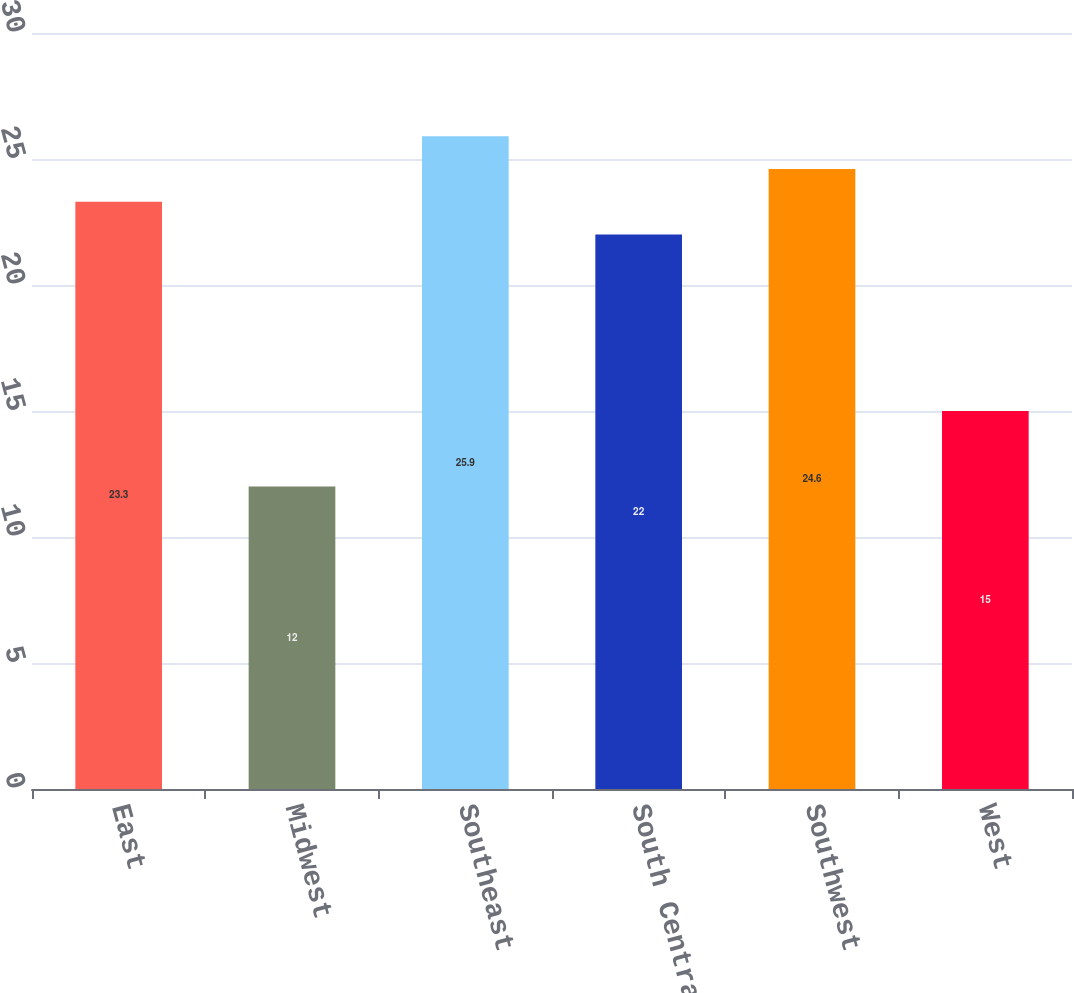Convert chart. <chart><loc_0><loc_0><loc_500><loc_500><bar_chart><fcel>East<fcel>Midwest<fcel>Southeast<fcel>South Central<fcel>Southwest<fcel>West<nl><fcel>23.3<fcel>12<fcel>25.9<fcel>22<fcel>24.6<fcel>15<nl></chart> 